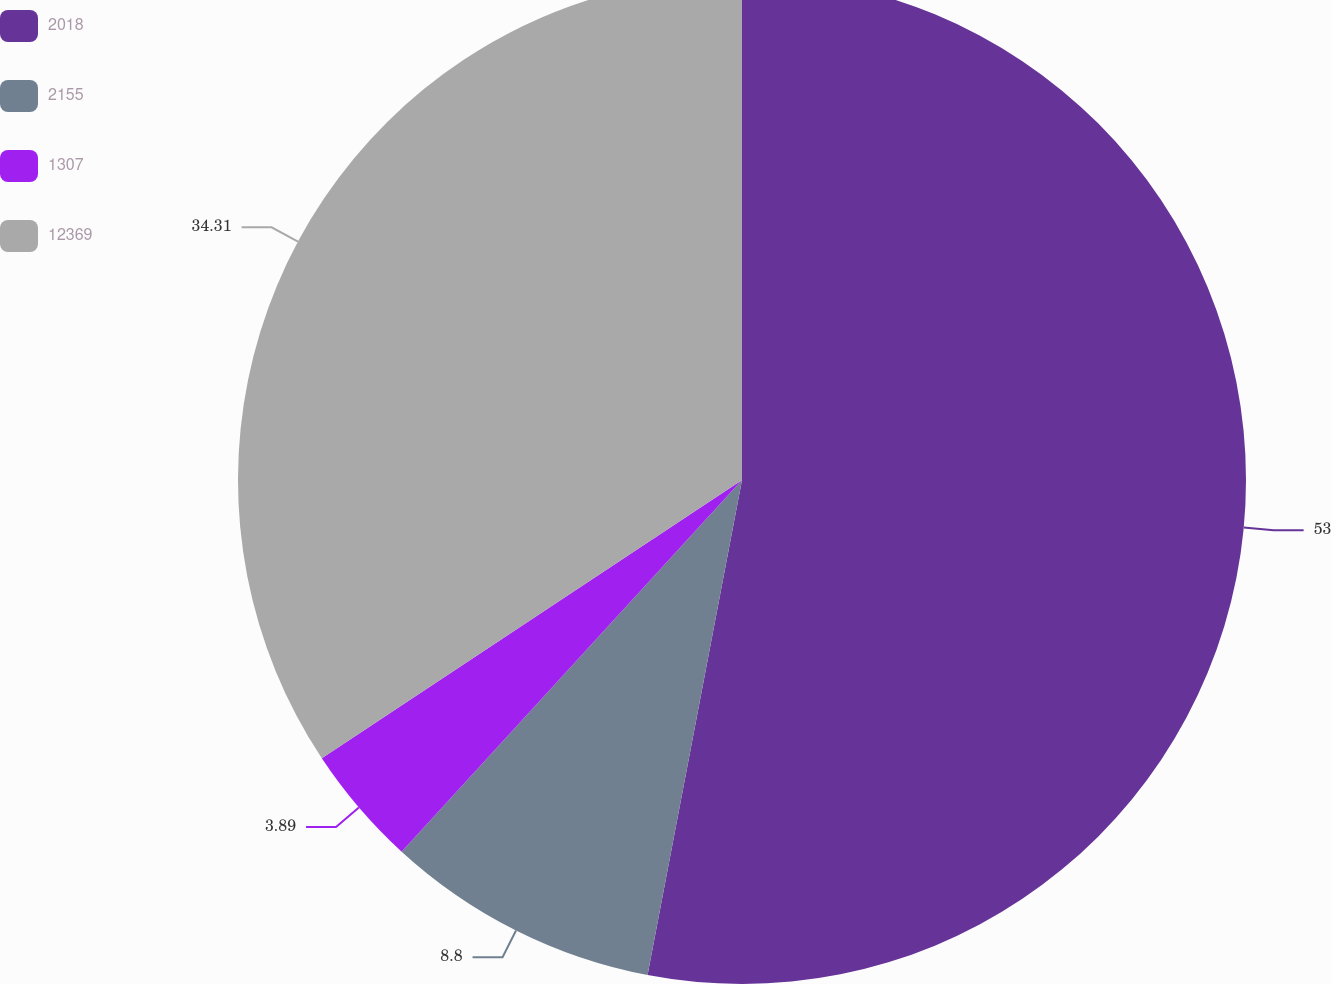<chart> <loc_0><loc_0><loc_500><loc_500><pie_chart><fcel>2018<fcel>2155<fcel>1307<fcel>12369<nl><fcel>53.0%<fcel>8.8%<fcel>3.89%<fcel>34.31%<nl></chart> 